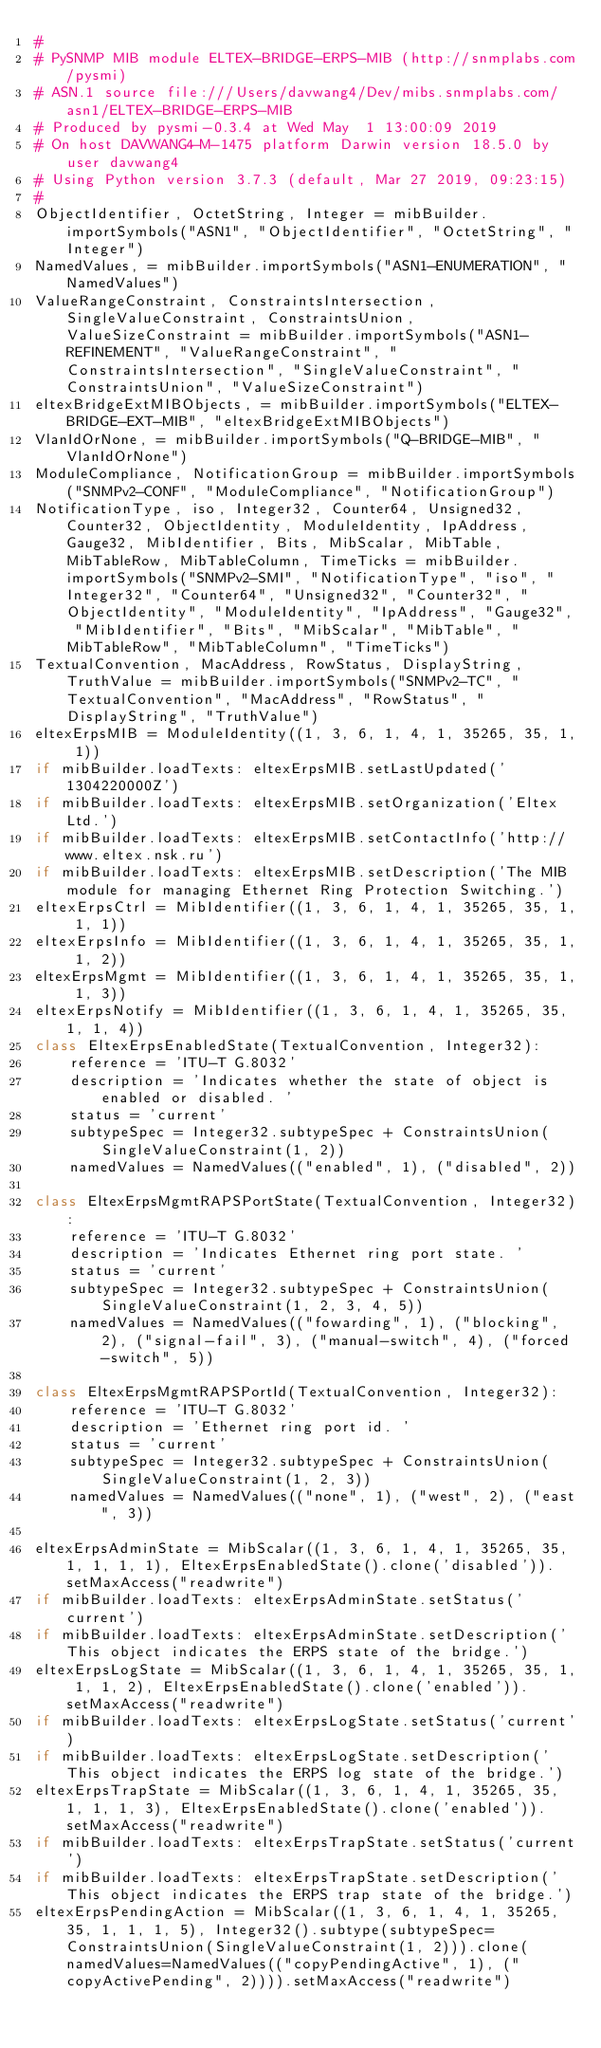Convert code to text. <code><loc_0><loc_0><loc_500><loc_500><_Python_>#
# PySNMP MIB module ELTEX-BRIDGE-ERPS-MIB (http://snmplabs.com/pysmi)
# ASN.1 source file:///Users/davwang4/Dev/mibs.snmplabs.com/asn1/ELTEX-BRIDGE-ERPS-MIB
# Produced by pysmi-0.3.4 at Wed May  1 13:00:09 2019
# On host DAVWANG4-M-1475 platform Darwin version 18.5.0 by user davwang4
# Using Python version 3.7.3 (default, Mar 27 2019, 09:23:15) 
#
ObjectIdentifier, OctetString, Integer = mibBuilder.importSymbols("ASN1", "ObjectIdentifier", "OctetString", "Integer")
NamedValues, = mibBuilder.importSymbols("ASN1-ENUMERATION", "NamedValues")
ValueRangeConstraint, ConstraintsIntersection, SingleValueConstraint, ConstraintsUnion, ValueSizeConstraint = mibBuilder.importSymbols("ASN1-REFINEMENT", "ValueRangeConstraint", "ConstraintsIntersection", "SingleValueConstraint", "ConstraintsUnion", "ValueSizeConstraint")
eltexBridgeExtMIBObjects, = mibBuilder.importSymbols("ELTEX-BRIDGE-EXT-MIB", "eltexBridgeExtMIBObjects")
VlanIdOrNone, = mibBuilder.importSymbols("Q-BRIDGE-MIB", "VlanIdOrNone")
ModuleCompliance, NotificationGroup = mibBuilder.importSymbols("SNMPv2-CONF", "ModuleCompliance", "NotificationGroup")
NotificationType, iso, Integer32, Counter64, Unsigned32, Counter32, ObjectIdentity, ModuleIdentity, IpAddress, Gauge32, MibIdentifier, Bits, MibScalar, MibTable, MibTableRow, MibTableColumn, TimeTicks = mibBuilder.importSymbols("SNMPv2-SMI", "NotificationType", "iso", "Integer32", "Counter64", "Unsigned32", "Counter32", "ObjectIdentity", "ModuleIdentity", "IpAddress", "Gauge32", "MibIdentifier", "Bits", "MibScalar", "MibTable", "MibTableRow", "MibTableColumn", "TimeTicks")
TextualConvention, MacAddress, RowStatus, DisplayString, TruthValue = mibBuilder.importSymbols("SNMPv2-TC", "TextualConvention", "MacAddress", "RowStatus", "DisplayString", "TruthValue")
eltexErpsMIB = ModuleIdentity((1, 3, 6, 1, 4, 1, 35265, 35, 1, 1))
if mibBuilder.loadTexts: eltexErpsMIB.setLastUpdated('1304220000Z')
if mibBuilder.loadTexts: eltexErpsMIB.setOrganization('Eltex Ltd.')
if mibBuilder.loadTexts: eltexErpsMIB.setContactInfo('http://www.eltex.nsk.ru')
if mibBuilder.loadTexts: eltexErpsMIB.setDescription('The MIB module for managing Ethernet Ring Protection Switching.')
eltexErpsCtrl = MibIdentifier((1, 3, 6, 1, 4, 1, 35265, 35, 1, 1, 1))
eltexErpsInfo = MibIdentifier((1, 3, 6, 1, 4, 1, 35265, 35, 1, 1, 2))
eltexErpsMgmt = MibIdentifier((1, 3, 6, 1, 4, 1, 35265, 35, 1, 1, 3))
eltexErpsNotify = MibIdentifier((1, 3, 6, 1, 4, 1, 35265, 35, 1, 1, 4))
class EltexErpsEnabledState(TextualConvention, Integer32):
    reference = 'ITU-T G.8032'
    description = 'Indicates whether the state of object is enabled or disabled. '
    status = 'current'
    subtypeSpec = Integer32.subtypeSpec + ConstraintsUnion(SingleValueConstraint(1, 2))
    namedValues = NamedValues(("enabled", 1), ("disabled", 2))

class EltexErpsMgmtRAPSPortState(TextualConvention, Integer32):
    reference = 'ITU-T G.8032'
    description = 'Indicates Ethernet ring port state. '
    status = 'current'
    subtypeSpec = Integer32.subtypeSpec + ConstraintsUnion(SingleValueConstraint(1, 2, 3, 4, 5))
    namedValues = NamedValues(("fowarding", 1), ("blocking", 2), ("signal-fail", 3), ("manual-switch", 4), ("forced-switch", 5))

class EltexErpsMgmtRAPSPortId(TextualConvention, Integer32):
    reference = 'ITU-T G.8032'
    description = 'Ethernet ring port id. '
    status = 'current'
    subtypeSpec = Integer32.subtypeSpec + ConstraintsUnion(SingleValueConstraint(1, 2, 3))
    namedValues = NamedValues(("none", 1), ("west", 2), ("east", 3))

eltexErpsAdminState = MibScalar((1, 3, 6, 1, 4, 1, 35265, 35, 1, 1, 1, 1), EltexErpsEnabledState().clone('disabled')).setMaxAccess("readwrite")
if mibBuilder.loadTexts: eltexErpsAdminState.setStatus('current')
if mibBuilder.loadTexts: eltexErpsAdminState.setDescription('This object indicates the ERPS state of the bridge.')
eltexErpsLogState = MibScalar((1, 3, 6, 1, 4, 1, 35265, 35, 1, 1, 1, 2), EltexErpsEnabledState().clone('enabled')).setMaxAccess("readwrite")
if mibBuilder.loadTexts: eltexErpsLogState.setStatus('current')
if mibBuilder.loadTexts: eltexErpsLogState.setDescription('This object indicates the ERPS log state of the bridge.')
eltexErpsTrapState = MibScalar((1, 3, 6, 1, 4, 1, 35265, 35, 1, 1, 1, 3), EltexErpsEnabledState().clone('enabled')).setMaxAccess("readwrite")
if mibBuilder.loadTexts: eltexErpsTrapState.setStatus('current')
if mibBuilder.loadTexts: eltexErpsTrapState.setDescription('This object indicates the ERPS trap state of the bridge.')
eltexErpsPendingAction = MibScalar((1, 3, 6, 1, 4, 1, 35265, 35, 1, 1, 1, 5), Integer32().subtype(subtypeSpec=ConstraintsUnion(SingleValueConstraint(1, 2))).clone(namedValues=NamedValues(("copyPendingActive", 1), ("copyActivePending", 2)))).setMaxAccess("readwrite")</code> 